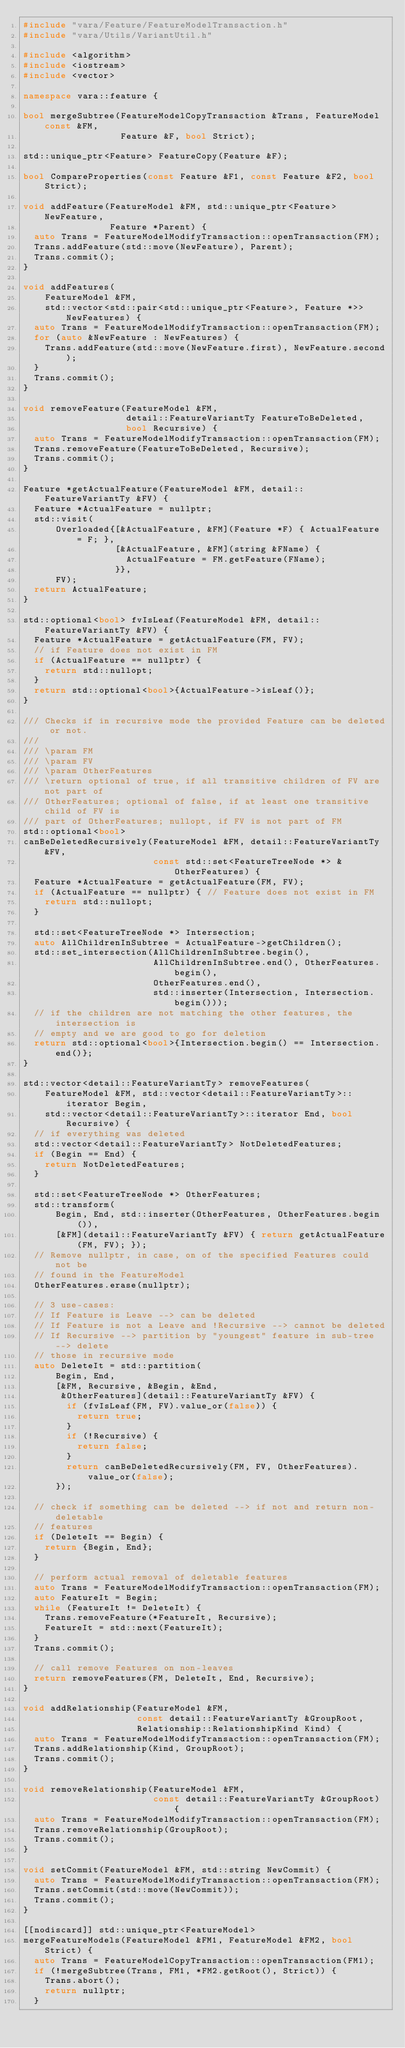<code> <loc_0><loc_0><loc_500><loc_500><_C++_>#include "vara/Feature/FeatureModelTransaction.h"
#include "vara/Utils/VariantUtil.h"

#include <algorithm>
#include <iostream>
#include <vector>

namespace vara::feature {

bool mergeSubtree(FeatureModelCopyTransaction &Trans, FeatureModel const &FM,
                  Feature &F, bool Strict);

std::unique_ptr<Feature> FeatureCopy(Feature &F);

bool CompareProperties(const Feature &F1, const Feature &F2, bool Strict);

void addFeature(FeatureModel &FM, std::unique_ptr<Feature> NewFeature,
                Feature *Parent) {
  auto Trans = FeatureModelModifyTransaction::openTransaction(FM);
  Trans.addFeature(std::move(NewFeature), Parent);
  Trans.commit();
}

void addFeatures(
    FeatureModel &FM,
    std::vector<std::pair<std::unique_ptr<Feature>, Feature *>> NewFeatures) {
  auto Trans = FeatureModelModifyTransaction::openTransaction(FM);
  for (auto &NewFeature : NewFeatures) {
    Trans.addFeature(std::move(NewFeature.first), NewFeature.second);
  }
  Trans.commit();
}

void removeFeature(FeatureModel &FM,
                   detail::FeatureVariantTy FeatureToBeDeleted,
                   bool Recursive) {
  auto Trans = FeatureModelModifyTransaction::openTransaction(FM);
  Trans.removeFeature(FeatureToBeDeleted, Recursive);
  Trans.commit();
}

Feature *getActualFeature(FeatureModel &FM, detail::FeatureVariantTy &FV) {
  Feature *ActualFeature = nullptr;
  std::visit(
      Overloaded{[&ActualFeature, &FM](Feature *F) { ActualFeature = F; },
                 [&ActualFeature, &FM](string &FName) {
                   ActualFeature = FM.getFeature(FName);
                 }},
      FV);
  return ActualFeature;
}

std::optional<bool> fvIsLeaf(FeatureModel &FM, detail::FeatureVariantTy &FV) {
  Feature *ActualFeature = getActualFeature(FM, FV);
  // if Feature does not exist in FM
  if (ActualFeature == nullptr) {
    return std::nullopt;
  }
  return std::optional<bool>{ActualFeature->isLeaf()};
}

/// Checks if in recursive mode the provided Feature can be deleted or not.
///
/// \param FM
/// \param FV
/// \param OtherFeatures
/// \return optional of true, if all transitive children of FV are not part of
/// OtherFeatures; optional of false, if at least one transitive child of FV is
/// part of OtherFeatures; nullopt, if FV is not part of FM
std::optional<bool>
canBeDeletedRecursively(FeatureModel &FM, detail::FeatureVariantTy &FV,
                        const std::set<FeatureTreeNode *> &OtherFeatures) {
  Feature *ActualFeature = getActualFeature(FM, FV);
  if (ActualFeature == nullptr) { // Feature does not exist in FM
    return std::nullopt;
  }

  std::set<FeatureTreeNode *> Intersection;
  auto AllChildrenInSubtree = ActualFeature->getChildren();
  std::set_intersection(AllChildrenInSubtree.begin(),
                        AllChildrenInSubtree.end(), OtherFeatures.begin(),
                        OtherFeatures.end(),
                        std::inserter(Intersection, Intersection.begin()));
  // if the children are not matching the other features, the intersection is
  // empty and we are good to go for deletion
  return std::optional<bool>{Intersection.begin() == Intersection.end()};
}

std::vector<detail::FeatureVariantTy> removeFeatures(
    FeatureModel &FM, std::vector<detail::FeatureVariantTy>::iterator Begin,
    std::vector<detail::FeatureVariantTy>::iterator End, bool Recursive) {
  // if everything was deleted
  std::vector<detail::FeatureVariantTy> NotDeletedFeatures;
  if (Begin == End) {
    return NotDeletedFeatures;
  }

  std::set<FeatureTreeNode *> OtherFeatures;
  std::transform(
      Begin, End, std::inserter(OtherFeatures, OtherFeatures.begin()),
      [&FM](detail::FeatureVariantTy &FV) { return getActualFeature(FM, FV); });
  // Remove nullptr, in case, on of the specified Features could not be
  // found in the FeatureModel
  OtherFeatures.erase(nullptr);

  // 3 use-cases:
  // If Feature is Leave --> can be deleted
  // If Feature is not a Leave and !Recursive --> cannot be deleted
  // If Recursive --> partition by "youngest" feature in sub-tree --> delete
  // those in recursive mode
  auto DeleteIt = std::partition(
      Begin, End,
      [&FM, Recursive, &Begin, &End,
       &OtherFeatures](detail::FeatureVariantTy &FV) {
        if (fvIsLeaf(FM, FV).value_or(false)) {
          return true;
        }
        if (!Recursive) {
          return false;
        }
        return canBeDeletedRecursively(FM, FV, OtherFeatures).value_or(false);
      });

  // check if something can be deleted --> if not and return non-deletable
  // features
  if (DeleteIt == Begin) {
    return {Begin, End};
  }

  // perform actual removal of deletable features
  auto Trans = FeatureModelModifyTransaction::openTransaction(FM);
  auto FeatureIt = Begin;
  while (FeatureIt != DeleteIt) {
    Trans.removeFeature(*FeatureIt, Recursive);
    FeatureIt = std::next(FeatureIt);
  }
  Trans.commit();

  // call remove Features on non-leaves
  return removeFeatures(FM, DeleteIt, End, Recursive);
}

void addRelationship(FeatureModel &FM,
                     const detail::FeatureVariantTy &GroupRoot,
                     Relationship::RelationshipKind Kind) {
  auto Trans = FeatureModelModifyTransaction::openTransaction(FM);
  Trans.addRelationship(Kind, GroupRoot);
  Trans.commit();
}

void removeRelationship(FeatureModel &FM,
                        const detail::FeatureVariantTy &GroupRoot) {
  auto Trans = FeatureModelModifyTransaction::openTransaction(FM);
  Trans.removeRelationship(GroupRoot);
  Trans.commit();
}

void setCommit(FeatureModel &FM, std::string NewCommit) {
  auto Trans = FeatureModelModifyTransaction::openTransaction(FM);
  Trans.setCommit(std::move(NewCommit));
  Trans.commit();
}

[[nodiscard]] std::unique_ptr<FeatureModel>
mergeFeatureModels(FeatureModel &FM1, FeatureModel &FM2, bool Strict) {
  auto Trans = FeatureModelCopyTransaction::openTransaction(FM1);
  if (!mergeSubtree(Trans, FM1, *FM2.getRoot(), Strict)) {
    Trans.abort();
    return nullptr;
  }</code> 